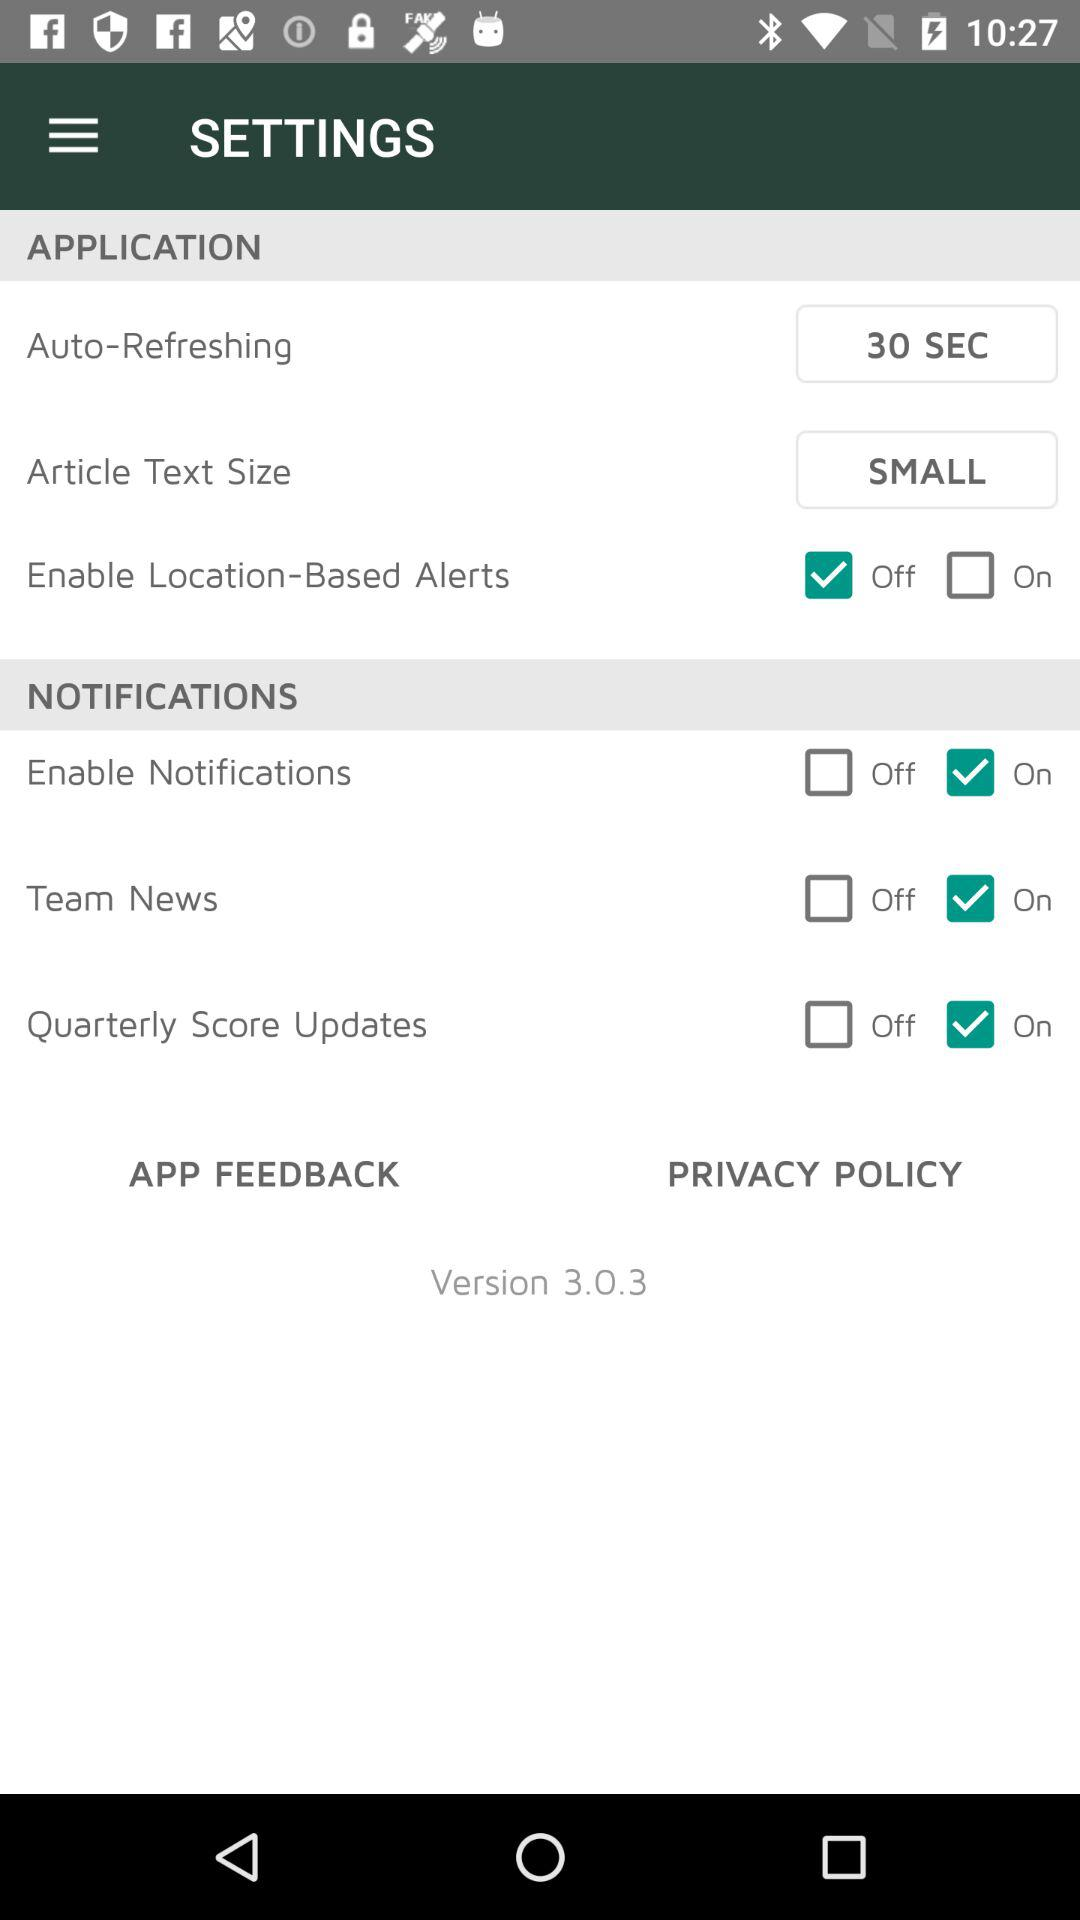Which version is this? This is version 3.0.3. 